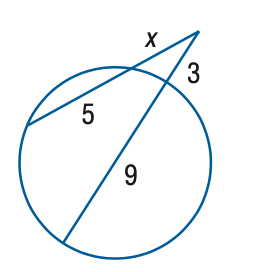Question: Find x to the nearest tenth. 
Choices:
A. 2
B. 3
C. 4
D. 5
Answer with the letter. Answer: C 